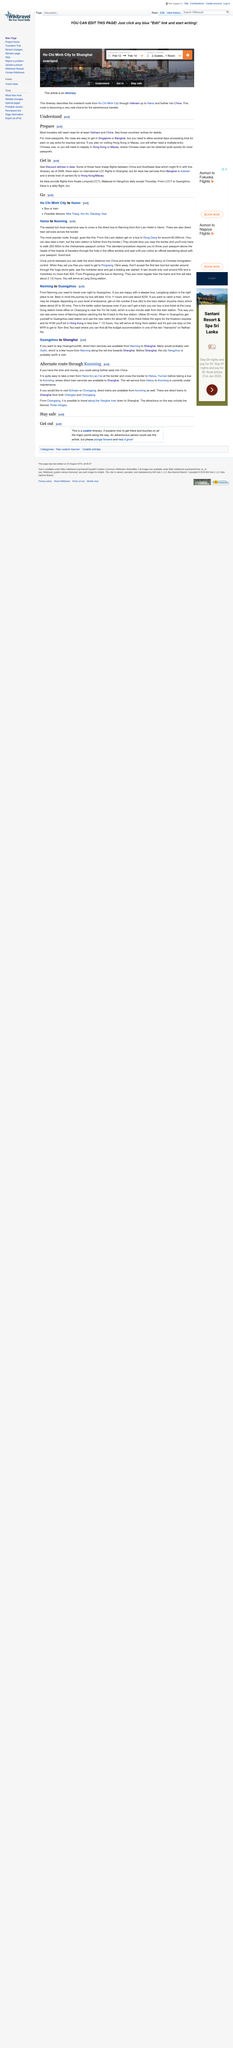Draw attention to some important aspects in this diagram. Direct train services are available from Kunming to Shanghai, enabling passengers to travel between the two cities with ease. Air Asia provides daily flights from Kuala Lumpur, Malaysia to Hangzhou, with the exception of Thursdays, according to the "Get in" section of the Hangzhou travel guide. There is a daily flight from LCCT to Guangzhou. The famous Three Gorges attraction is located along the Yangtze river down to Shanghai, which are popular tourist destinations. There were no international low-cost carrier flights to Shanghai as of 2006. 